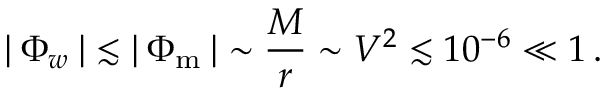Convert formula to latex. <formula><loc_0><loc_0><loc_500><loc_500>| \, \Phi _ { w } \, | \, \lesssim \, | \, \Phi _ { m } \, | \, \sim \frac { M } { r } \sim V ^ { 2 } \lesssim 1 0 ^ { - 6 } \ll 1 \, .</formula> 